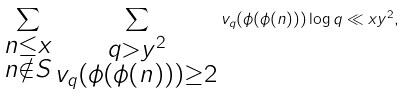Convert formula to latex. <formula><loc_0><loc_0><loc_500><loc_500>\sum _ { \substack { n \leq x \\ n \notin S } } \sum _ { \substack { q > y ^ { 2 } \\ v _ { q } ( \phi ( \phi ( n ) ) ) \geq 2 } } v _ { q } ( \phi ( \phi ( n ) ) ) \log q \ll x y ^ { 2 } ,</formula> 